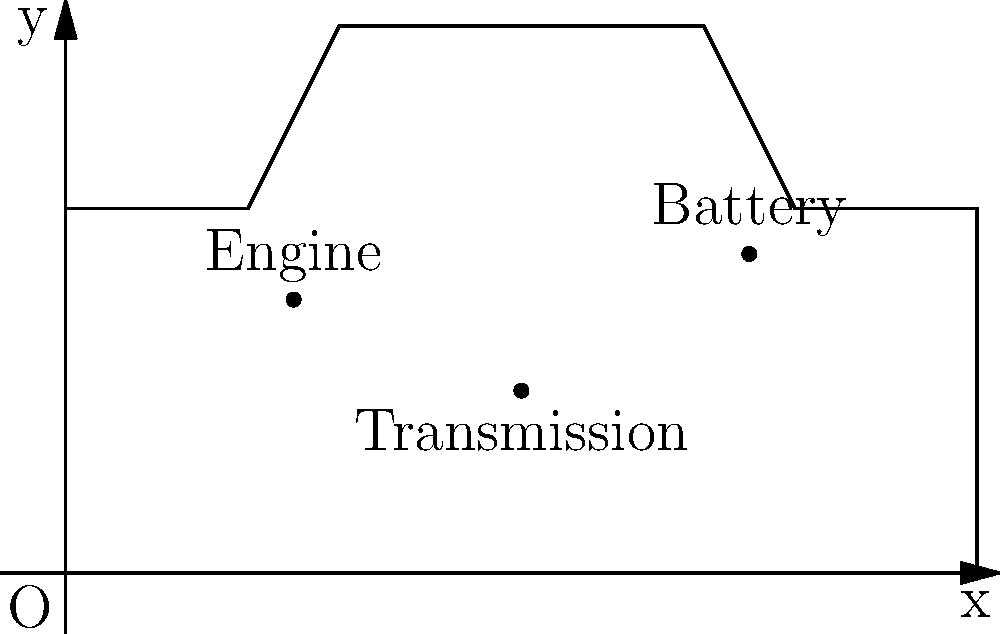A car's weight distribution is crucial for optimal performance. The coordinates of key components in a car are given as follows: Engine (25, 30), Transmission (50, 20), and Battery (75, 35). Assuming these are the only major components affecting weight distribution, calculate the x-coordinate of the center of gravity. Round your answer to the nearest whole number. To find the center of gravity, we need to calculate the weighted average of the x-coordinates. Let's assume each component has the following weights:

Engine: 300 kg
Transmission: 150 kg
Battery: 50 kg

Step 1: Calculate the total weight
Total weight = 300 + 150 + 50 = 500 kg

Step 2: Calculate the moment (weight × distance) for each component
Engine moment: 300 × 25 = 7500 kg·cm
Transmission moment: 150 × 50 = 7500 kg·cm
Battery moment: 50 × 75 = 3750 kg·cm

Step 3: Calculate the total moment
Total moment = 7500 + 7500 + 3750 = 18750 kg·cm

Step 4: Calculate the x-coordinate of the center of gravity
$$x_{CG} = \frac{\text{Total moment}}{\text{Total weight}} = \frac{18750}{500} = 37.5\text{ cm}$$

Step 5: Round to the nearest whole number
37.5 cm rounds to 38 cm

Therefore, the x-coordinate of the center of gravity is 38 cm.
Answer: 38 cm 